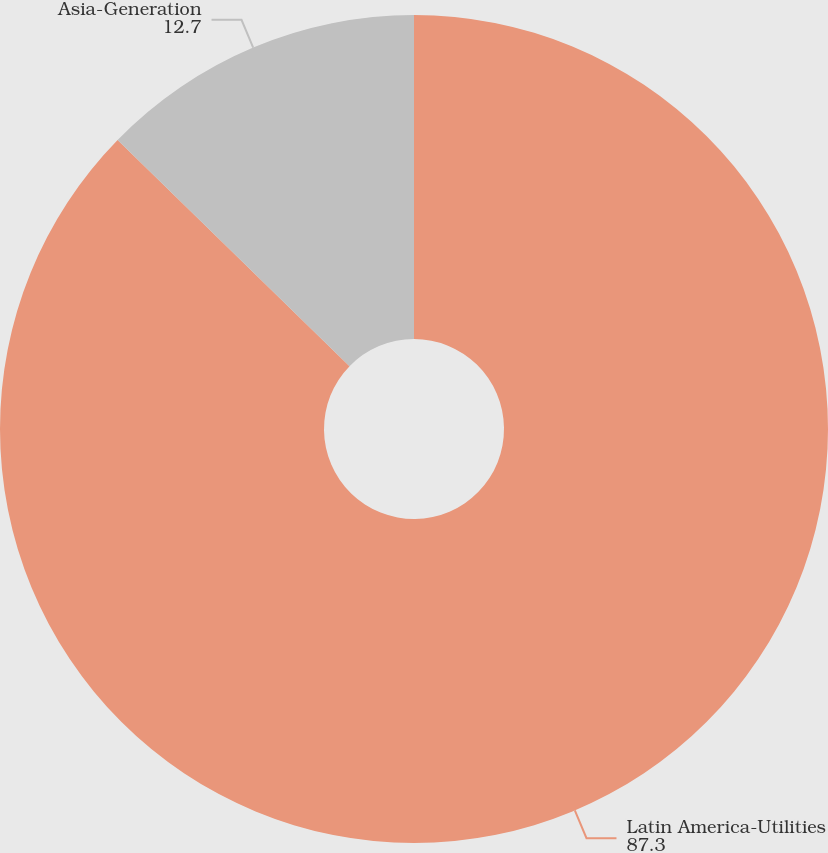Convert chart. <chart><loc_0><loc_0><loc_500><loc_500><pie_chart><fcel>Latin America-Utilities<fcel>Asia-Generation<nl><fcel>87.3%<fcel>12.7%<nl></chart> 